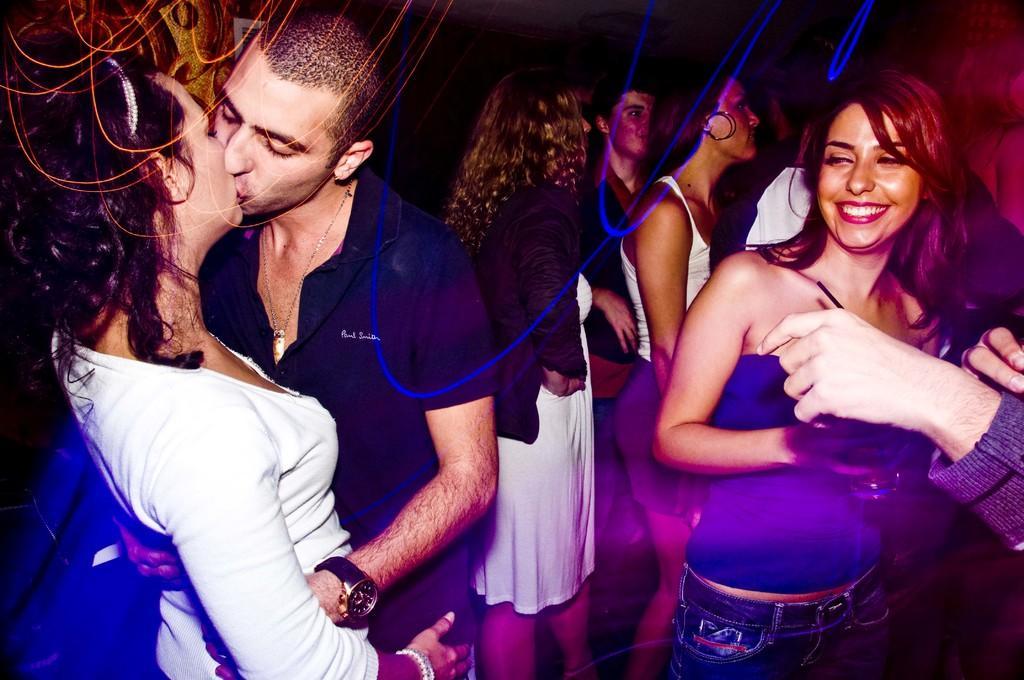How would you summarize this image in a sentence or two? In this picture we can observe some people standing. We can observe women and a man. In the background it is dark. We can observe blue color lines in this picture. 